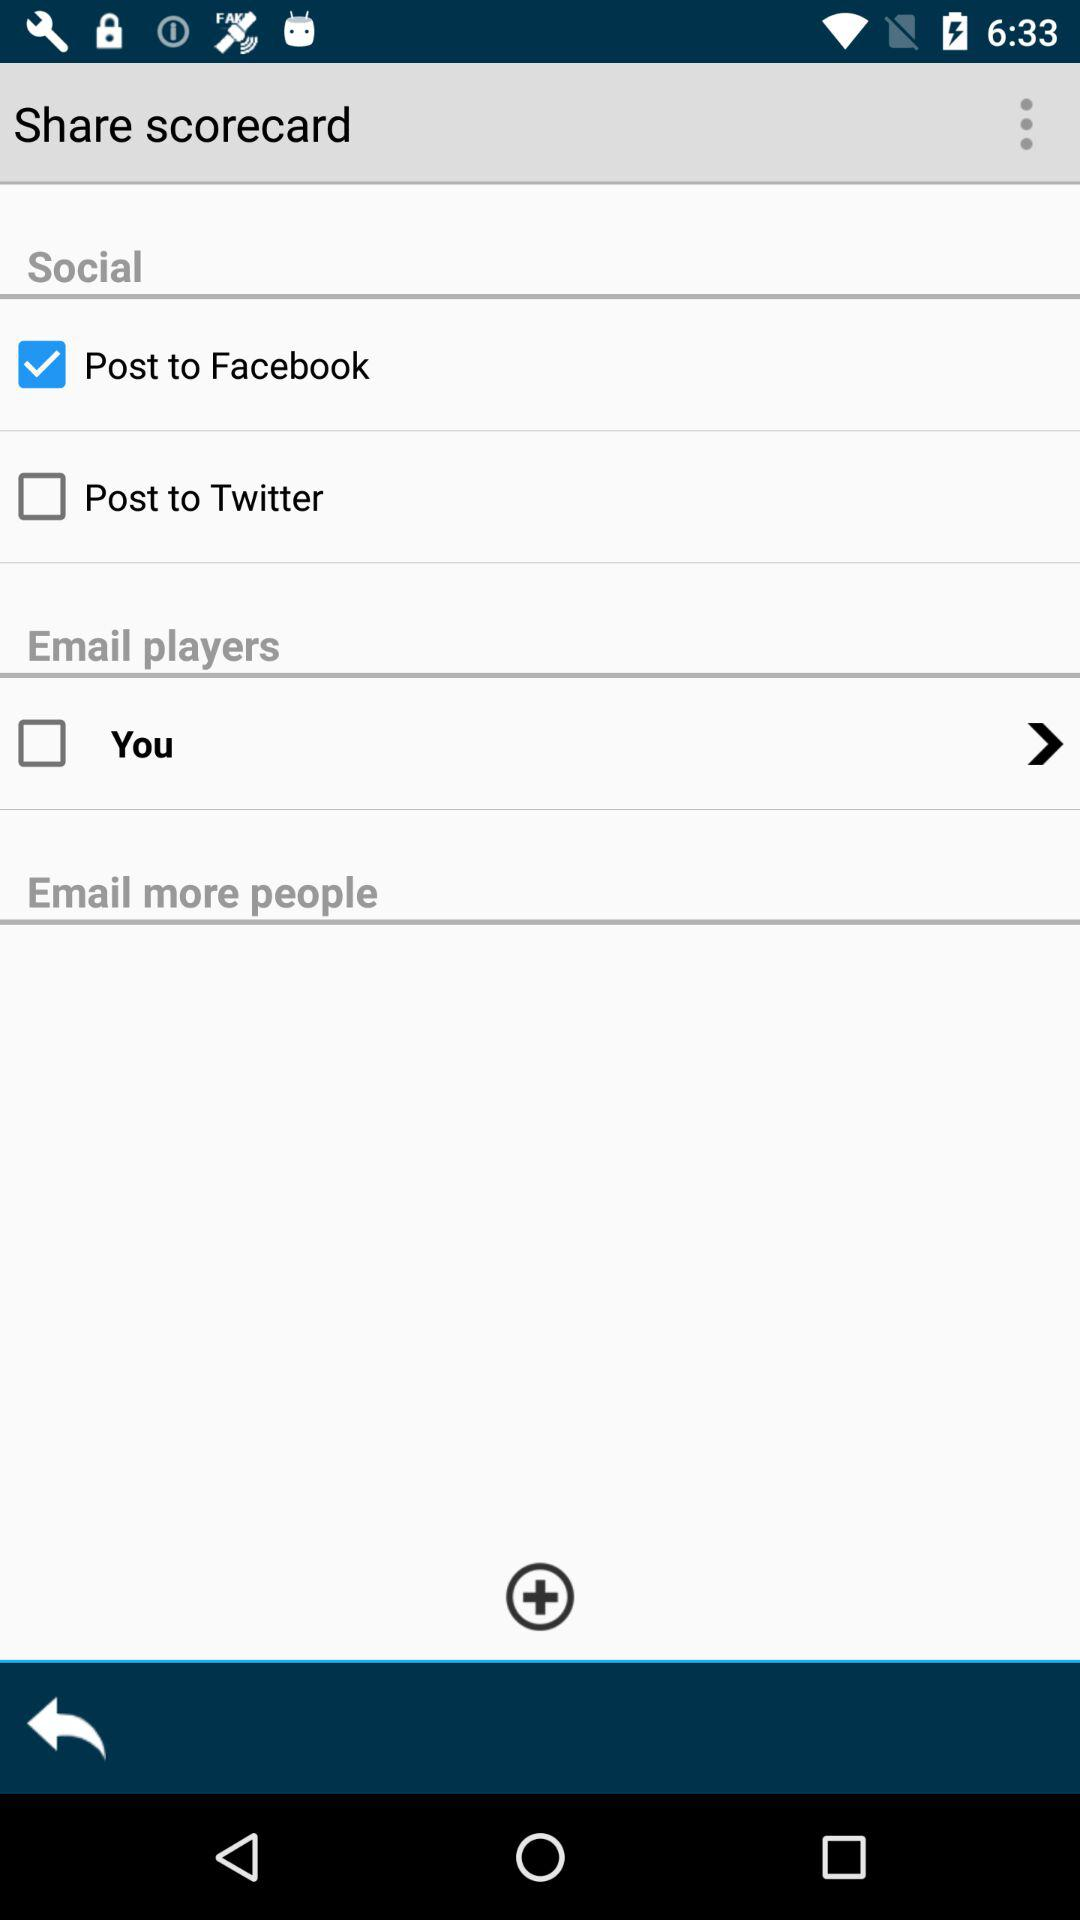How many more social sharing options are there than email sharing options, excluding the 'You' checkbox?
Answer the question using a single word or phrase. 1 